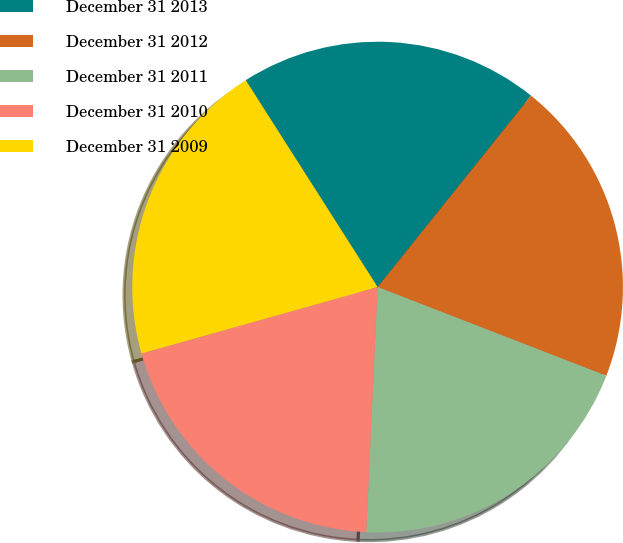<chart> <loc_0><loc_0><loc_500><loc_500><pie_chart><fcel>December 31 2013<fcel>December 31 2012<fcel>December 31 2011<fcel>December 31 2010<fcel>December 31 2009<nl><fcel>19.79%<fcel>20.13%<fcel>19.85%<fcel>19.9%<fcel>20.33%<nl></chart> 